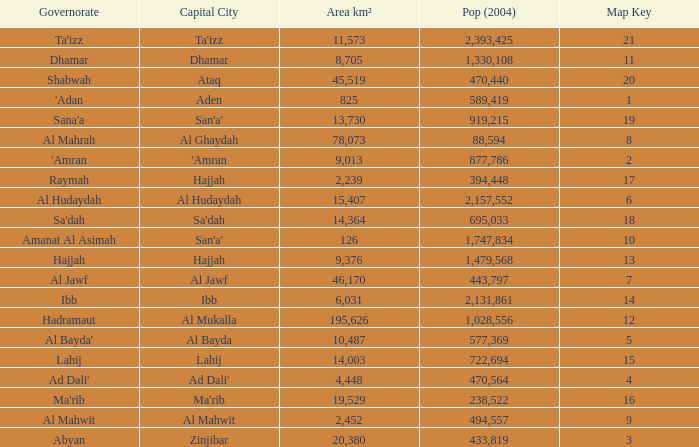Name the amount of Map Key which has a Pop (2004) smaller than 433,819, and a Capital City of hajjah, and an Area km² smaller than 9,376? Question 1 17.0. 